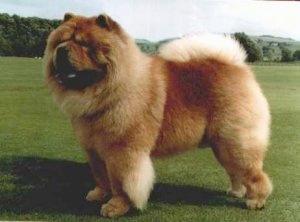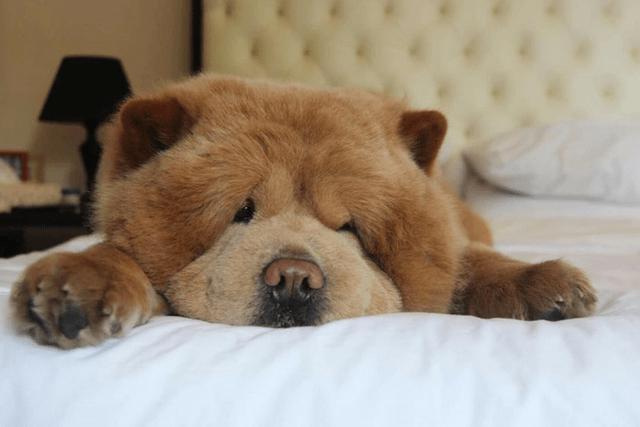The first image is the image on the left, the second image is the image on the right. Analyze the images presented: Is the assertion "There are two chow chows outside in the grass." valid? Answer yes or no. No. 